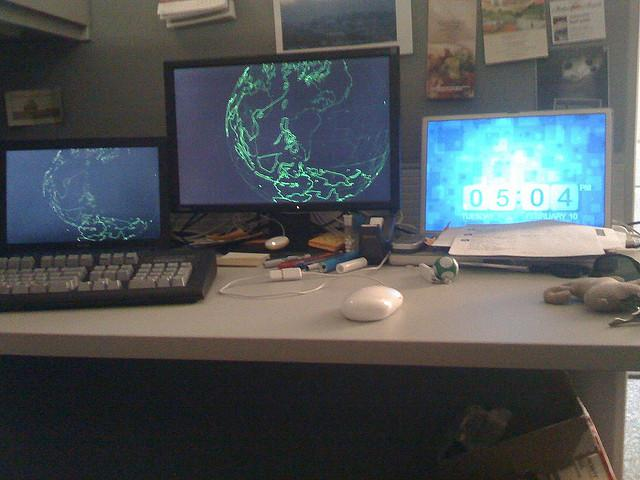What does the white mouse on the table do? controls computer 